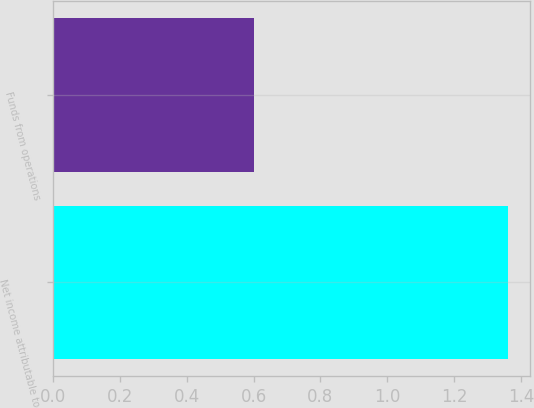Convert chart to OTSL. <chart><loc_0><loc_0><loc_500><loc_500><bar_chart><fcel>Net income attributable to<fcel>Funds from operations<nl><fcel>1.36<fcel>0.6<nl></chart> 